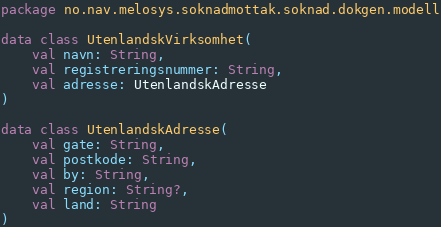<code> <loc_0><loc_0><loc_500><loc_500><_Kotlin_>package no.nav.melosys.soknadmottak.soknad.dokgen.modell

data class UtenlandskVirksomhet(
    val navn: String,
    val registreringsnummer: String,
    val adresse: UtenlandskAdresse
)

data class UtenlandskAdresse(
    val gate: String,
    val postkode: String,
    val by: String,
    val region: String?,
    val land: String
)
</code> 